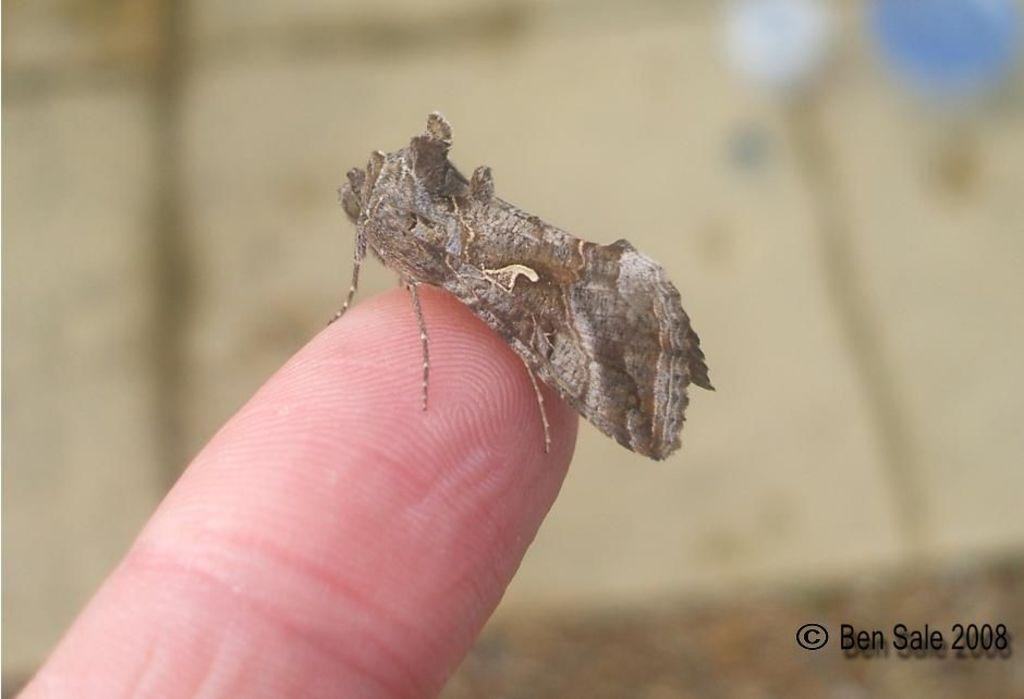What is present on the person's finger in the image? There is an insect on the person's finger in the image. Can you describe the insect in the image? Unfortunately, the image does not provide enough detail to describe the insect. What level of the building is the carpenter working on in the image? There is no carpenter or building present in the image; it only features an insect on a person's finger. How many horses can be seen in the image? There are no horses present in the image; it only features an insect on a person's finger. 